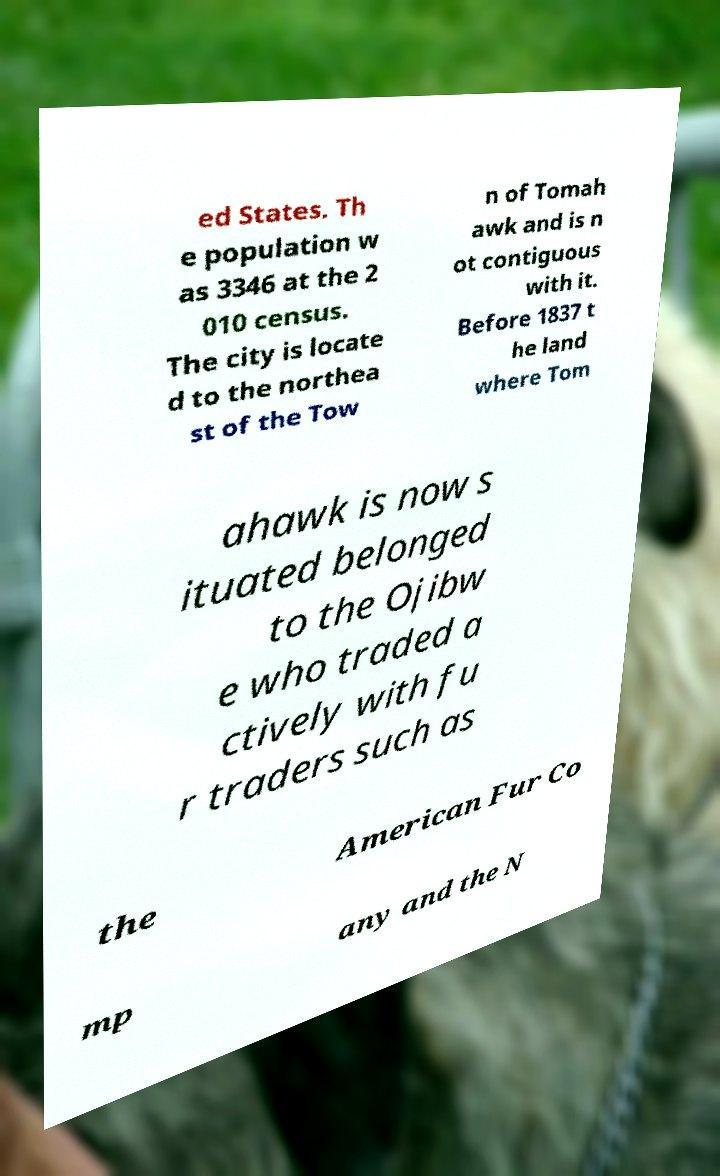Please identify and transcribe the text found in this image. ed States. Th e population w as 3346 at the 2 010 census. The city is locate d to the northea st of the Tow n of Tomah awk and is n ot contiguous with it. Before 1837 t he land where Tom ahawk is now s ituated belonged to the Ojibw e who traded a ctively with fu r traders such as the American Fur Co mp any and the N 